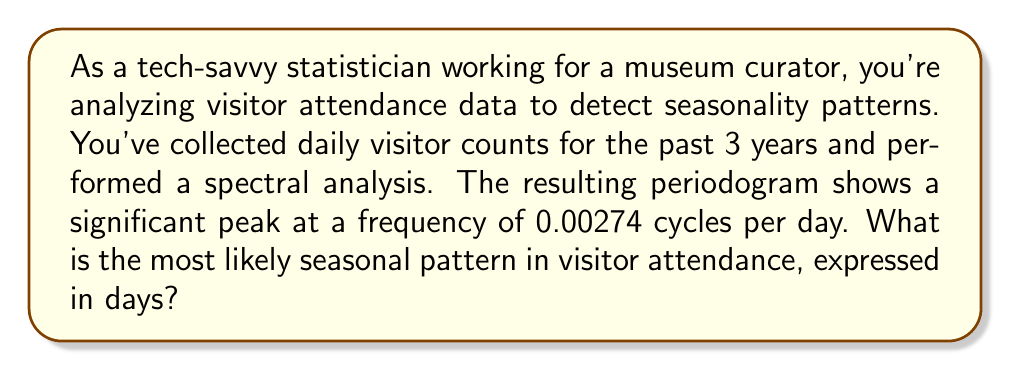Teach me how to tackle this problem. To solve this problem, we need to understand the relationship between frequency and period in spectral analysis:

1. The frequency (f) is given in cycles per day: 0.00274 cycles/day

2. The period (T) is the reciprocal of the frequency:

   $$T = \frac{1}{f}$$

3. Substituting the given frequency:

   $$T = \frac{1}{0.00274}$$

4. Calculate the result:

   $$T \approx 365.0365 \text{ days}$$

5. Interpret the result:
   The period of approximately 365 days suggests an annual seasonality pattern in visitor attendance.

This makes sense in the context of a museum, as visitor numbers often fluctuate with seasons, holidays, and yearly events. The slight difference from exactly 365 days (0.0365 days, or about 52 minutes) is likely due to rounding in the frequency value or minor variations in the data.

As a tech-savvy statistician, you would report to the curator that the spectral analysis reveals a strong annual seasonality pattern in visitor attendance, which could be used to inform staffing, exhibition planning, and marketing strategies.
Answer: 365 days (annual seasonality) 